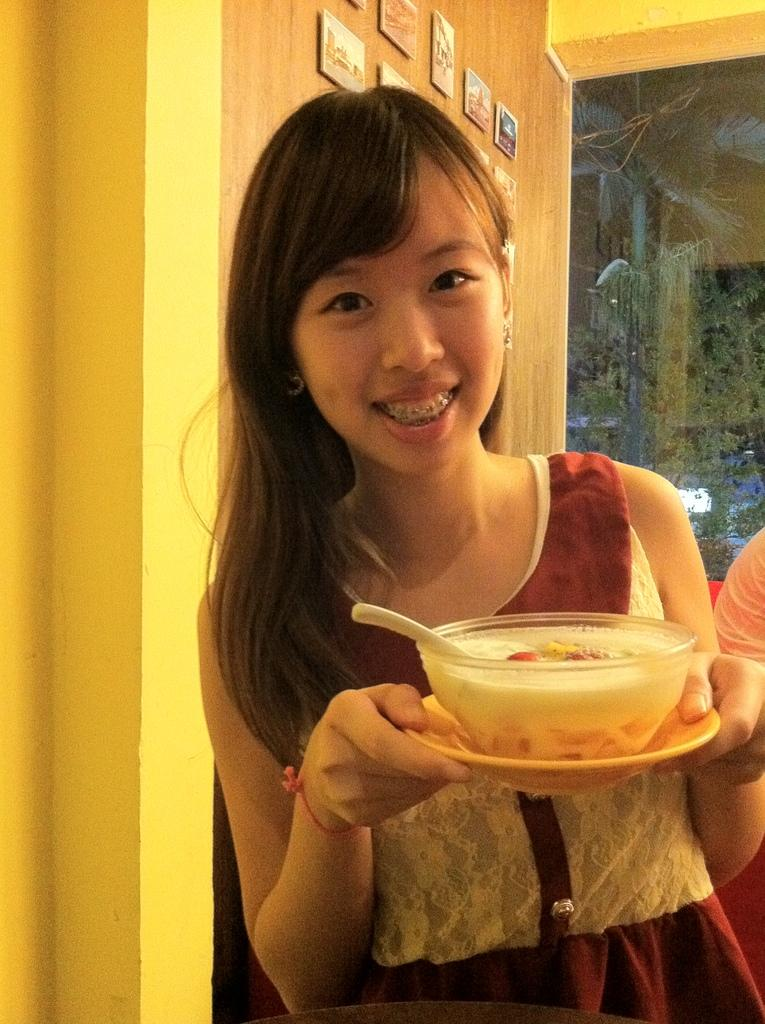What is the person in the image doing? The person is smiling in the image. What is the person holding in the image? The person is holding a plate in the image. What is on the plate that the person is holding? The plate contains a bowl of food item and a spoon. What can be seen on the wall in the image? There are photo frames on a wall in the image. What is the other visible object in the image? There is a glass visible in the image. How long does it take for the train to pass by in the image? There is no train present in the image, so it is not possible to determine how long it would take for a train to pass by. 